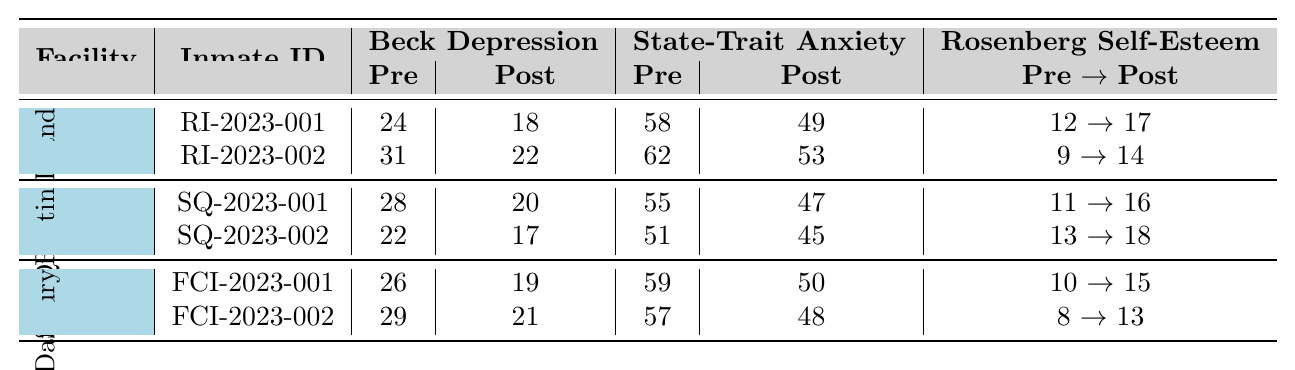What was the pre-intervention Beck Depression Inventory score for inmate RI-2023-001? The table shows that the pre-intervention Beck Depression Inventory score for inmate RI-2023-001 is 24.
Answer: 24 Which facility had the lowest post-intervention score for the State-Trait Anxiety Inventory? Looking at the post-intervention scores for the State-Trait Anxiety Inventory, FCI Danbury has the lowest score of 50.
Answer: 50 What change in score did inmate SQ-2023-002 experience in the Rosenberg Self-Esteem Scale? The pre-intervention Rosenberg Self-Esteem Scale score for inmate SQ-2023-002 is 13 and the post-intervention score is 18. The change is 18 - 13 = 5.
Answer: 5 Did any of the inmates show an improvement in the Beck Depression Inventory scores? By comparing pre- and post-intervention scores for the Beck Depression Inventory, all inmates have lower scores after the intervention, indicating improvement.
Answer: Yes Which inmate had the highest score in the State-Trait Anxiety Inventory before the intervention? The highest pre-intervention State-Trait Anxiety Inventory score is 62, which belongs to inmate RI-2023-002.
Answer: RI-2023-002 What was the average change in scores for the Rosenberg Self-Esteem Scale across all inmates? The changes in scores are: RI-2023-001: 5, RI-2023-002: 5, SQ-2023-001: 5, SQ-2023-002: 5, FCI-2023-001: 5, FCI-2023-002: 5. The average change is (5 + 5 + 5 + 5 + 5 + 5)/6 = 5.
Answer: 5 Which inmate had the largest drop in the Beck Depression Inventory score? Inmate RI-2023-002 dropped from 31 to 22, a change of 9; this is larger than all other drops in the Beck Depression Inventory.
Answer: RI-2023-002 What is the total number of participants included in the study from Rikers Island? The table indicates there are 2 participants from Rikers Island listed in the data.
Answer: 2 Which facility had a higher average post-intervention Rosenberg Self-Esteem Scale score, Rikers Island or San Quentin? Rikers Island average post score = (17 + 14) / 2 = 15.5; San Quentin average post score = (16 + 18) / 2 = 17. San Quentin has a higher average post score.
Answer: San Quentin Was there any inmate who had a pre-intervention score of 8 or lower in the Rosenberg Self-Esteem Scale? The table shows that the lowest pre-intervention score in the Rosenberg Self-Esteem Scale is 8 from inmate FCI-2023-002.
Answer: Yes How many inmates in the study experienced a reduction in State-Trait Anxiety Inventory scores? All the inmates show a decrease in their State-Trait Anxiety Inventory scores, confirming that all 6 participants experienced a reduction.
Answer: 6 